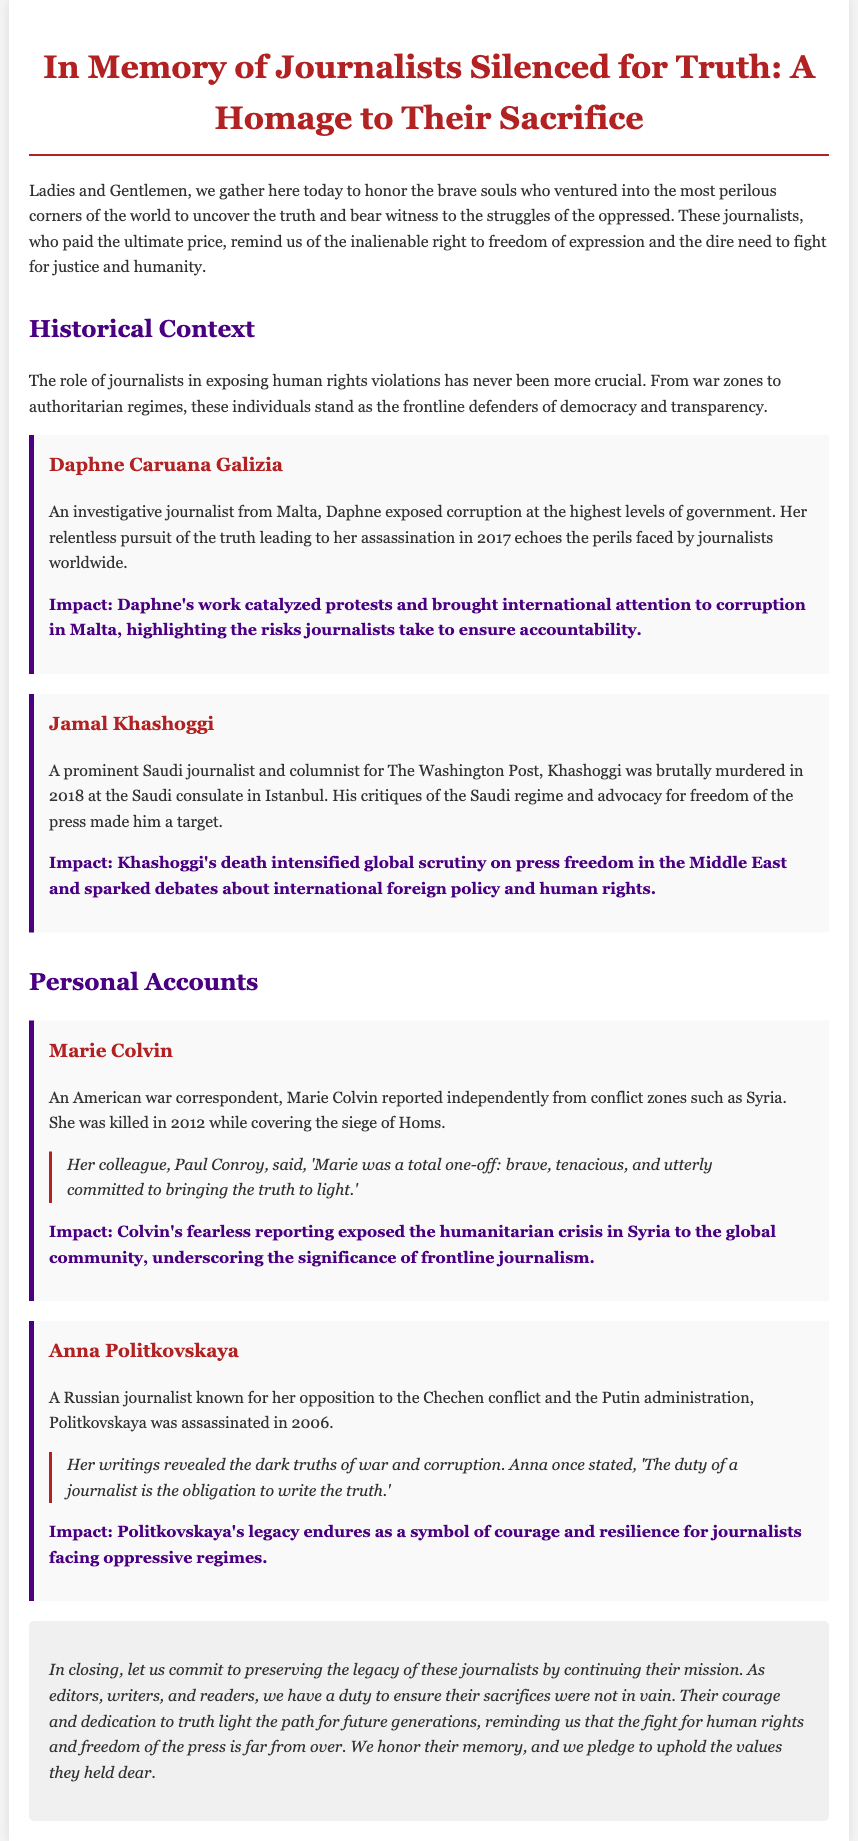what is the title of the document? The title is found at the top of the document and is stated clearly.
Answer: In Memory of Journalists Silenced for Truth: A Homage to Their Sacrifice who is the first journalist mentioned in the document? The first journalist is listed in the initial sections of the document under the "Historical Context."
Answer: Daphne Caruana Galizia when was Daphne Caruana Galizia assassinated? The year of her assassination is provided in her segment.
Answer: 2017 what was Jamal Khashoggi's profession? His profession is specified in the introduction of his section.
Answer: Journalist what did Marie Colvin cover before her death? The type of conflict she reported on is mentioned in her description.
Answer: Syria what is Anna Politkovskaya known for opposing? The document states her opposition in her specific section.
Answer: The Chechen conflict what is the impact mentioned regarding Khashoggi's death? The impact of his death is discussed as a significant consequence in his section.
Answer: Intensified global scrutiny on press freedom in the Middle East what is a common theme regarding the journalists featured? The document discusses their shared experiences and challenges faced.
Answer: Courage and sacrifice for truth what is the closing commitment of the eulogy? The final paragraph mentions a commitment that reflects the overall message of the document.
Answer: Preserving the legacy of these journalists 